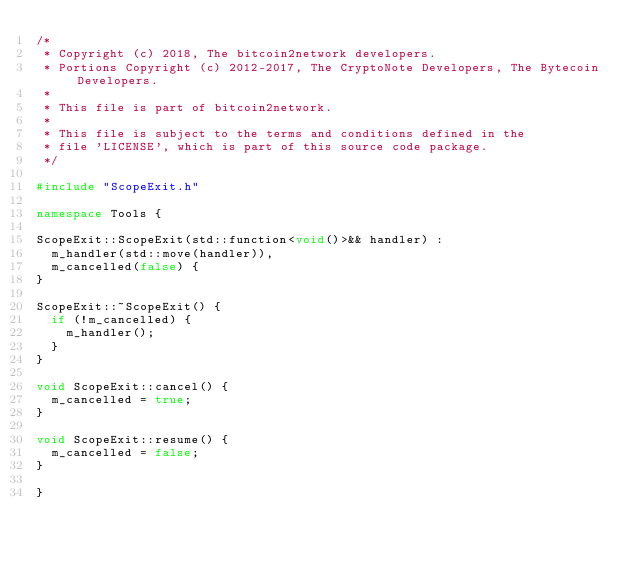Convert code to text. <code><loc_0><loc_0><loc_500><loc_500><_C++_>/*
 * Copyright (c) 2018, The bitcoin2network developers.
 * Portions Copyright (c) 2012-2017, The CryptoNote Developers, The Bytecoin Developers.
 *
 * This file is part of bitcoin2network.
 *
 * This file is subject to the terms and conditions defined in the
 * file 'LICENSE', which is part of this source code package.
 */

#include "ScopeExit.h"

namespace Tools {

ScopeExit::ScopeExit(std::function<void()>&& handler) :
  m_handler(std::move(handler)),
  m_cancelled(false) {
}

ScopeExit::~ScopeExit() {
  if (!m_cancelled) {
    m_handler();
  }
}

void ScopeExit::cancel() {
  m_cancelled = true;
}

void ScopeExit::resume() {
  m_cancelled = false;
}

}
</code> 